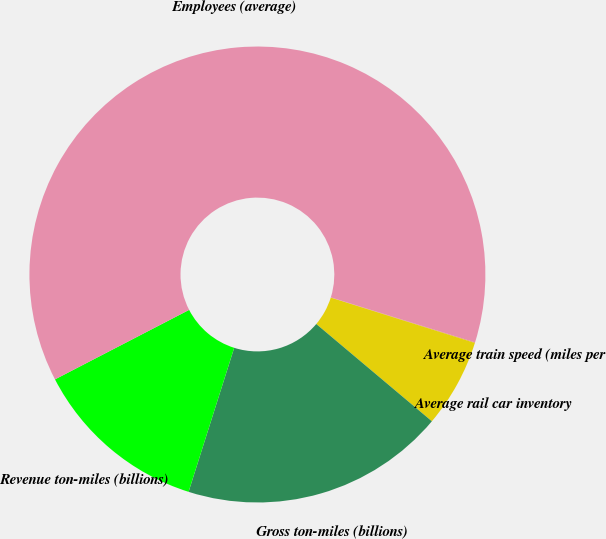<chart> <loc_0><loc_0><loc_500><loc_500><pie_chart><fcel>Average train speed (miles per<fcel>Average rail car inventory<fcel>Gross ton-miles (billions)<fcel>Revenue ton-miles (billions)<fcel>Employees (average)<nl><fcel>0.04%<fcel>6.28%<fcel>18.75%<fcel>12.51%<fcel>62.42%<nl></chart> 